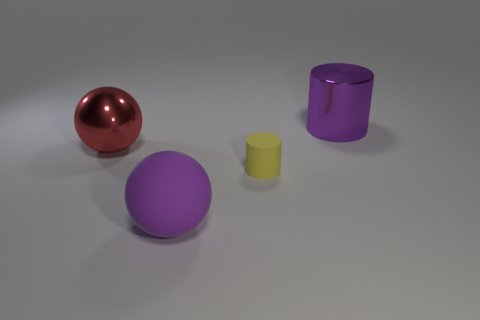Add 2 purple objects. How many objects exist? 6 Add 3 cyan matte cubes. How many cyan matte cubes exist? 3 Subtract 1 red spheres. How many objects are left? 3 Subtract all purple metallic cylinders. Subtract all small yellow rubber blocks. How many objects are left? 3 Add 2 tiny rubber cylinders. How many tiny rubber cylinders are left? 3 